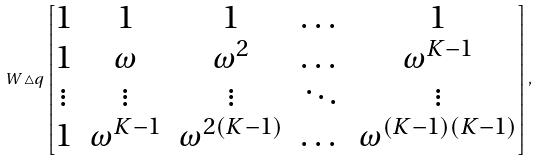<formula> <loc_0><loc_0><loc_500><loc_500>W \triangle q \begin{bmatrix} 1 & 1 & 1 & \dots & 1 \\ 1 & \omega & \omega ^ { 2 } & \dots & \omega ^ { K - 1 } \\ \vdots & \vdots & \vdots & \ddots & \vdots \\ 1 & \omega ^ { K - 1 } & \omega ^ { 2 ( K - 1 ) } & \dots & \omega ^ { ( K - 1 ) ( K - 1 ) } \end{bmatrix} ,</formula> 